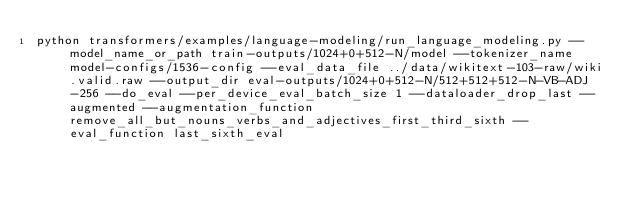<code> <loc_0><loc_0><loc_500><loc_500><_Bash_>python transformers/examples/language-modeling/run_language_modeling.py --model_name_or_path train-outputs/1024+0+512-N/model --tokenizer_name model-configs/1536-config --eval_data_file ../data/wikitext-103-raw/wiki.valid.raw --output_dir eval-outputs/1024+0+512-N/512+512+512-N-VB-ADJ-256 --do_eval --per_device_eval_batch_size 1 --dataloader_drop_last --augmented --augmentation_function remove_all_but_nouns_verbs_and_adjectives_first_third_sixth --eval_function last_sixth_eval</code> 